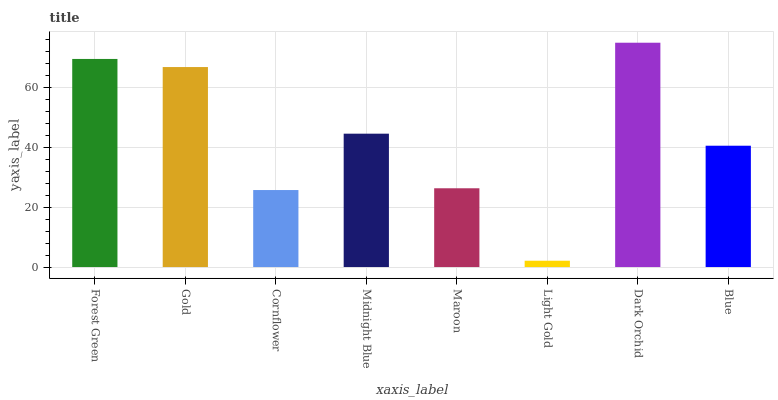Is Light Gold the minimum?
Answer yes or no. Yes. Is Dark Orchid the maximum?
Answer yes or no. Yes. Is Gold the minimum?
Answer yes or no. No. Is Gold the maximum?
Answer yes or no. No. Is Forest Green greater than Gold?
Answer yes or no. Yes. Is Gold less than Forest Green?
Answer yes or no. Yes. Is Gold greater than Forest Green?
Answer yes or no. No. Is Forest Green less than Gold?
Answer yes or no. No. Is Midnight Blue the high median?
Answer yes or no. Yes. Is Blue the low median?
Answer yes or no. Yes. Is Dark Orchid the high median?
Answer yes or no. No. Is Gold the low median?
Answer yes or no. No. 